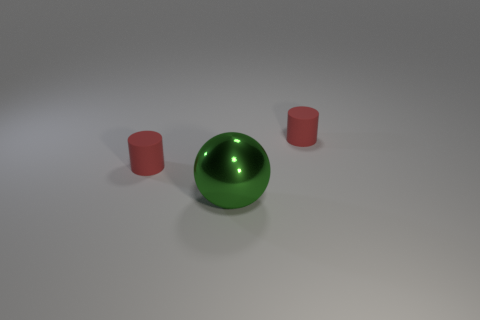Is there anything else that has the same material as the large green ball?
Offer a very short reply. No. What number of other green metal balls are the same size as the green ball?
Offer a very short reply. 0. Is the small red cylinder to the right of the ball made of the same material as the small cylinder left of the metallic object?
Provide a short and direct response. Yes. Are there more red cylinders than large cylinders?
Offer a terse response. Yes. Are there fewer balls than big yellow metallic things?
Keep it short and to the point. No. The sphere is what color?
Your answer should be very brief. Green. What number of other objects are there of the same material as the large green ball?
Keep it short and to the point. 0. How many yellow things are either rubber cylinders or balls?
Your answer should be very brief. 0. There is a rubber thing right of the metallic thing; is its shape the same as the small red matte thing left of the big green thing?
Provide a succinct answer. Yes. What number of things are either big metal balls or rubber objects that are right of the sphere?
Your response must be concise. 2. 